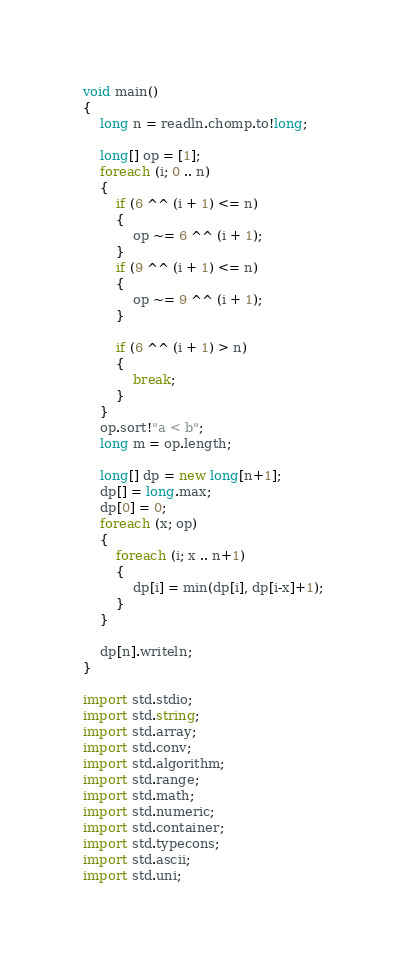<code> <loc_0><loc_0><loc_500><loc_500><_D_>void main()
{
    long n = readln.chomp.to!long;

    long[] op = [1];
    foreach (i; 0 .. n)
    {
        if (6 ^^ (i + 1) <= n)
        {
            op ~= 6 ^^ (i + 1);
        }
        if (9 ^^ (i + 1) <= n)
        {
            op ~= 9 ^^ (i + 1);
        }

        if (6 ^^ (i + 1) > n)
        {
            break;
        }
    }
    op.sort!"a < b";
    long m = op.length;

    long[] dp = new long[n+1];
    dp[] = long.max;
    dp[0] = 0;
    foreach (x; op)
    {
        foreach (i; x .. n+1)
        {
            dp[i] = min(dp[i], dp[i-x]+1);
        }
    }

    dp[n].writeln;
}

import std.stdio;
import std.string;
import std.array;
import std.conv;
import std.algorithm;
import std.range;
import std.math;
import std.numeric;
import std.container;
import std.typecons;
import std.ascii;
import std.uni;</code> 